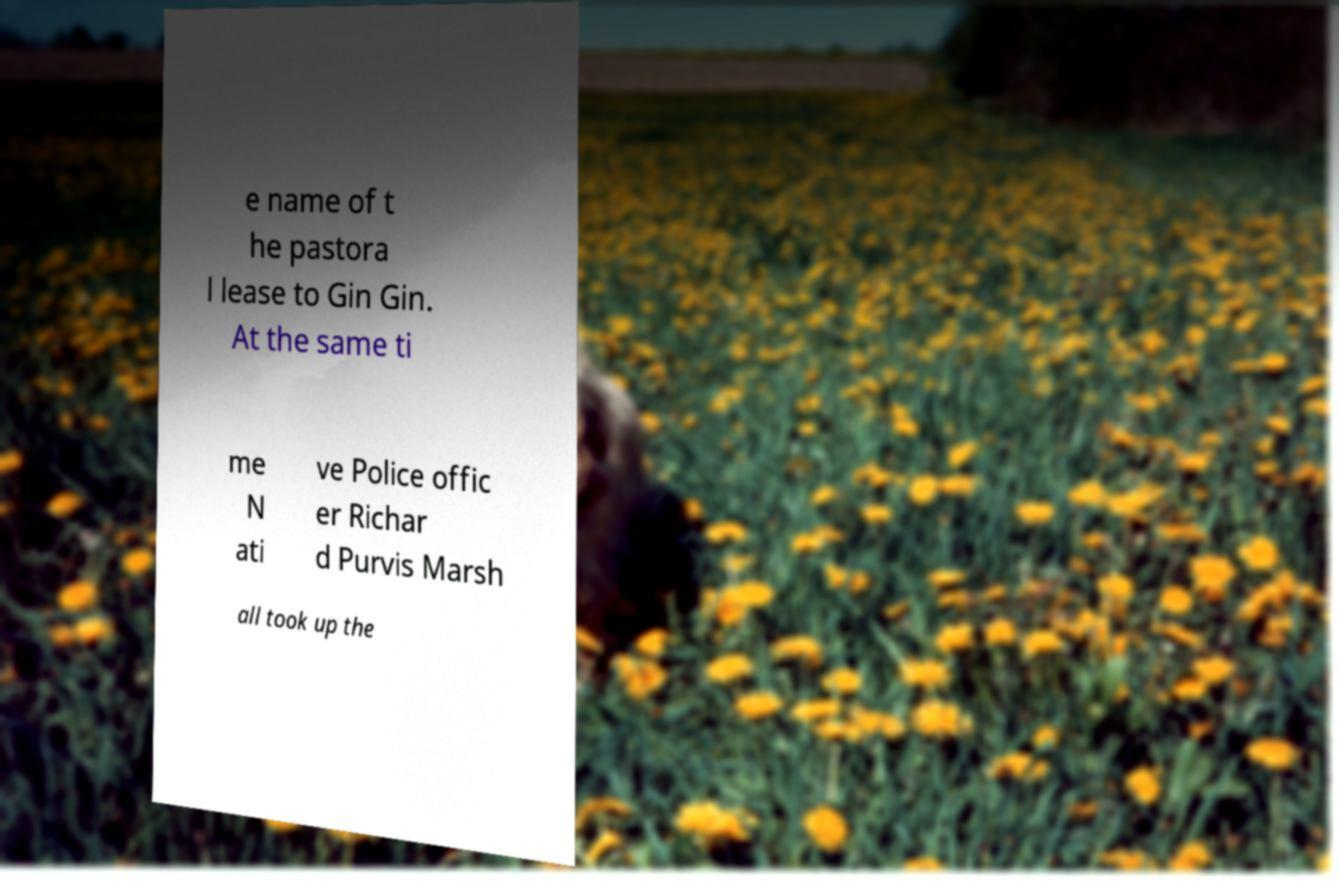Please identify and transcribe the text found in this image. e name of t he pastora l lease to Gin Gin. At the same ti me N ati ve Police offic er Richar d Purvis Marsh all took up the 